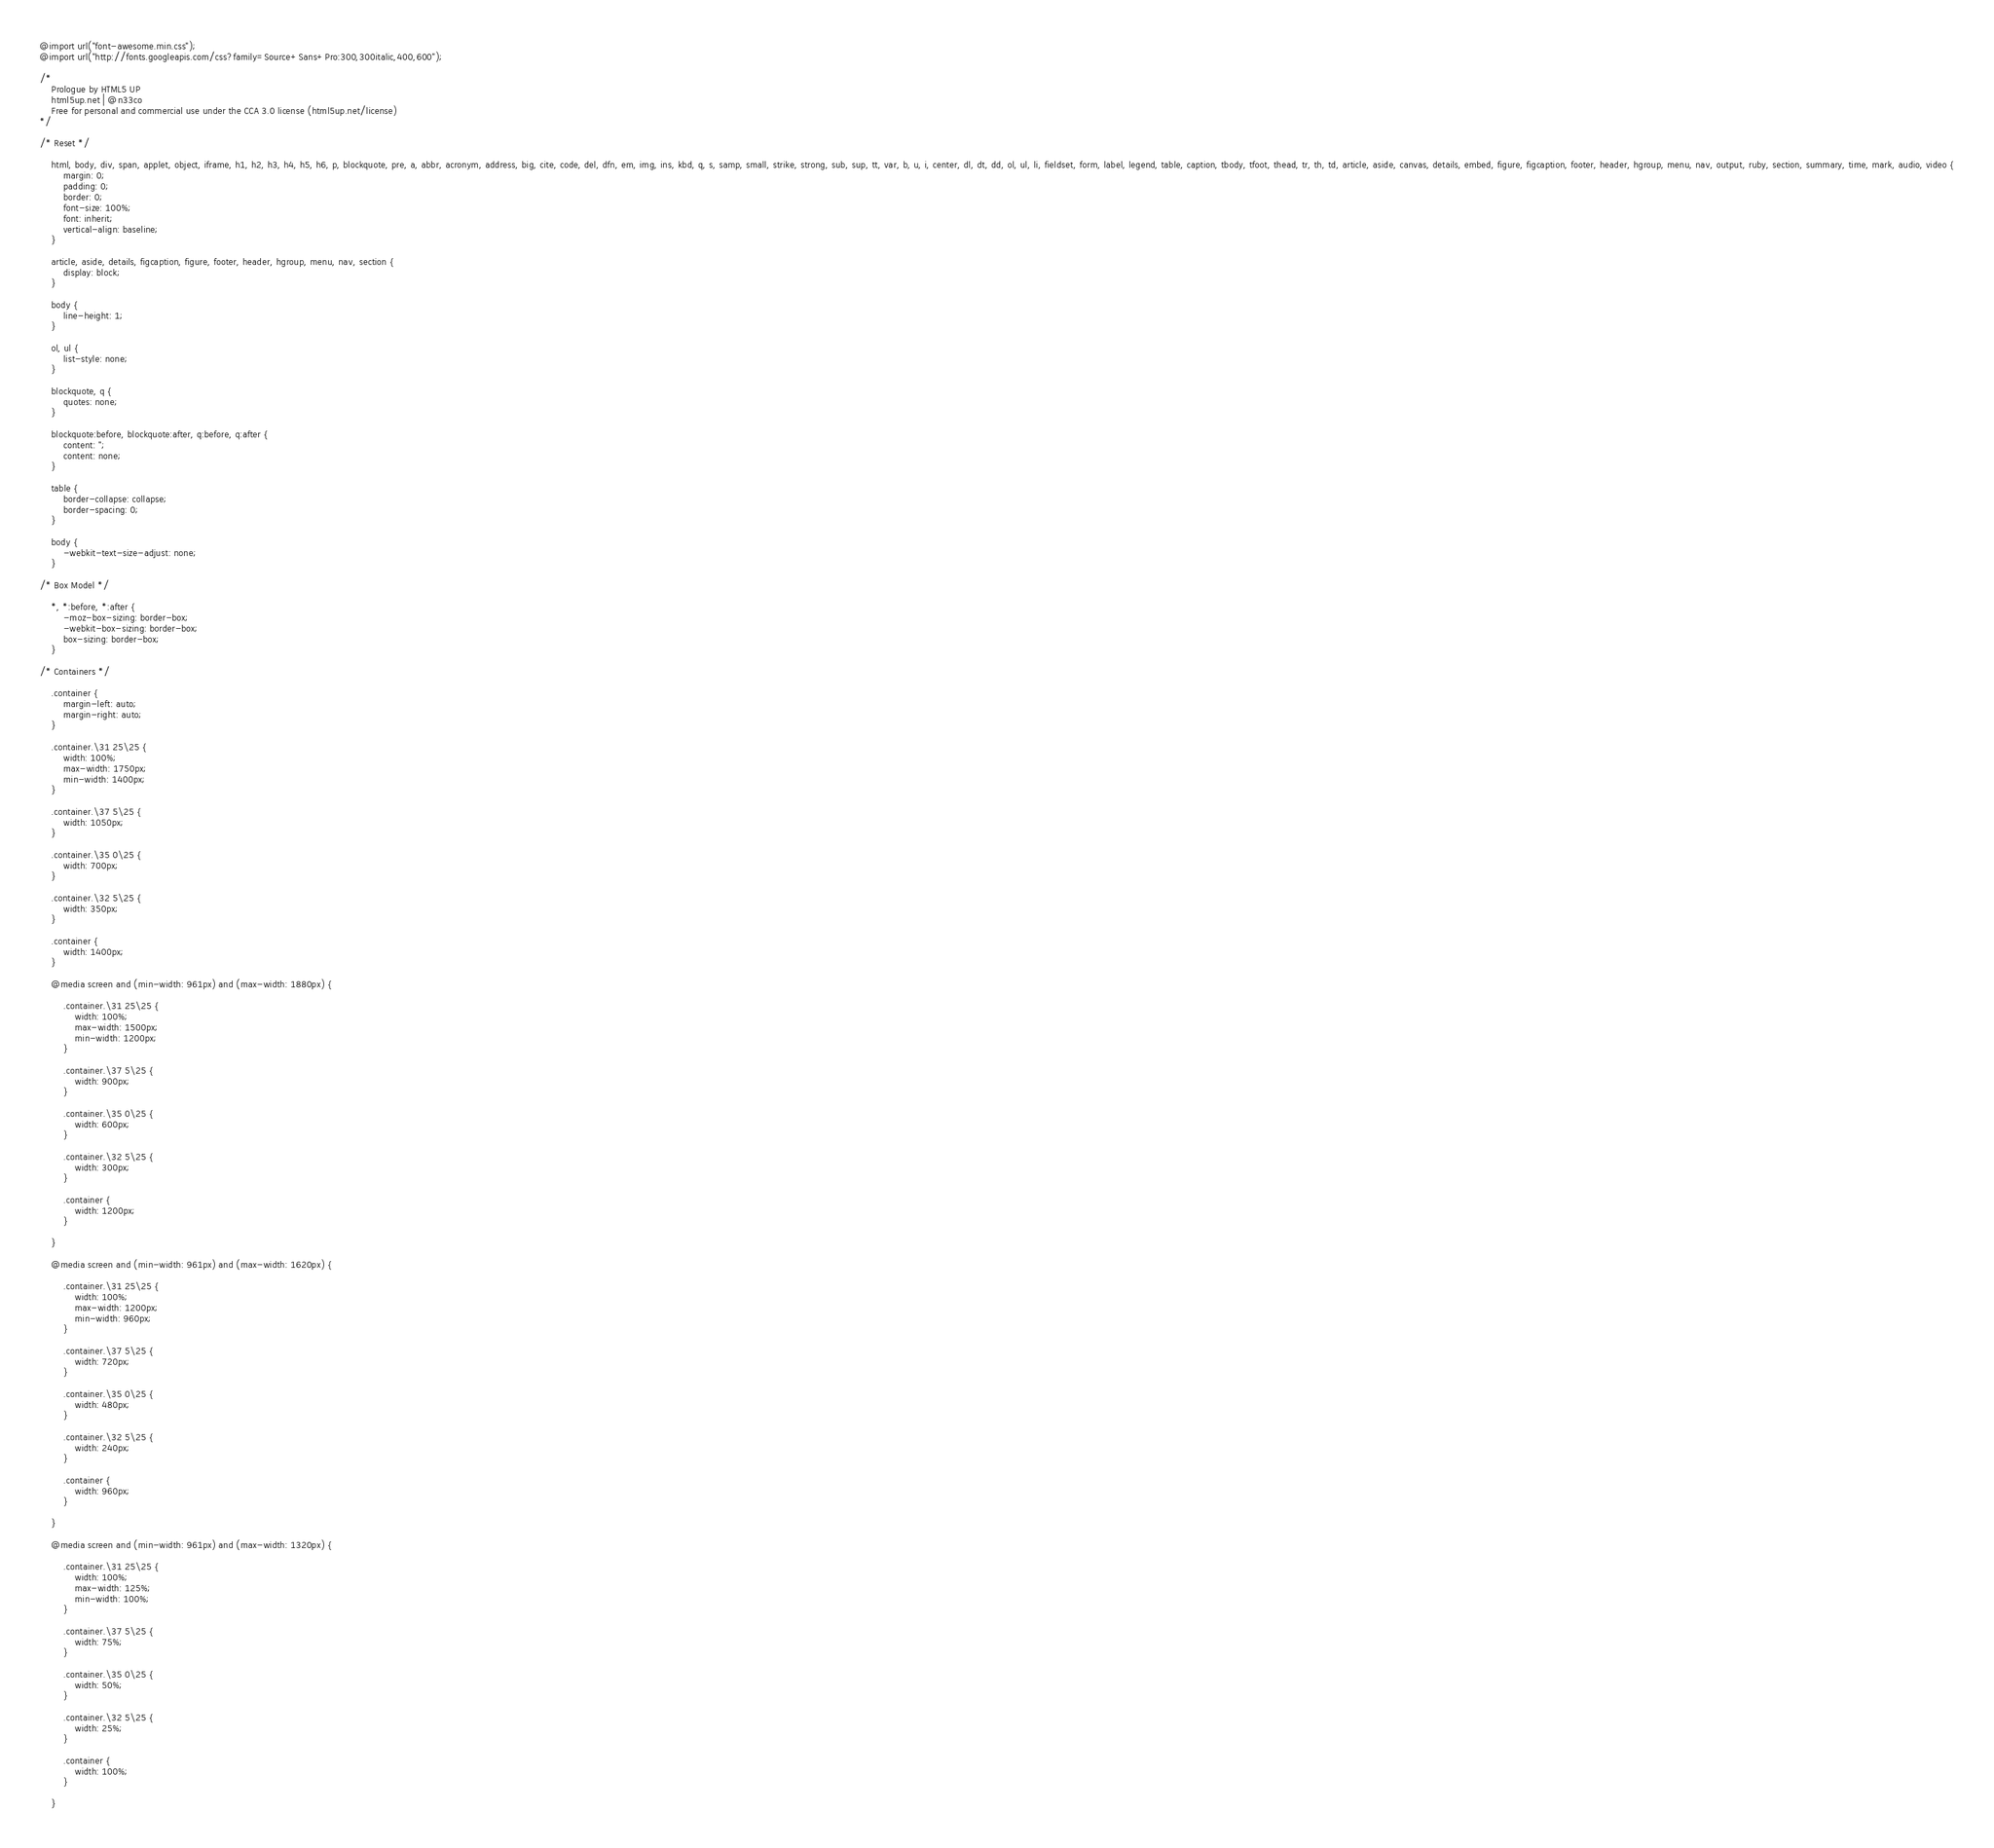Convert code to text. <code><loc_0><loc_0><loc_500><loc_500><_CSS_>@import url("font-awesome.min.css");
@import url("http://fonts.googleapis.com/css?family=Source+Sans+Pro:300,300italic,400,600");

/*
	Prologue by HTML5 UP
	html5up.net | @n33co
	Free for personal and commercial use under the CCA 3.0 license (html5up.net/license)
*/

/* Reset */

	html, body, div, span, applet, object, iframe, h1, h2, h3, h4, h5, h6, p, blockquote, pre, a, abbr, acronym, address, big, cite, code, del, dfn, em, img, ins, kbd, q, s, samp, small, strike, strong, sub, sup, tt, var, b, u, i, center, dl, dt, dd, ol, ul, li, fieldset, form, label, legend, table, caption, tbody, tfoot, thead, tr, th, td, article, aside, canvas, details, embed, figure, figcaption, footer, header, hgroup, menu, nav, output, ruby, section, summary, time, mark, audio, video {
		margin: 0;
		padding: 0;
		border: 0;
		font-size: 100%;
		font: inherit;
		vertical-align: baseline;
	}

	article, aside, details, figcaption, figure, footer, header, hgroup, menu, nav, section {
		display: block;
	}

	body {
		line-height: 1;
	}

	ol, ul {
		list-style: none;
	}

	blockquote, q {
		quotes: none;
	}

	blockquote:before, blockquote:after, q:before, q:after {
		content: '';
		content: none;
	}

	table {
		border-collapse: collapse;
		border-spacing: 0;
	}

	body {
		-webkit-text-size-adjust: none;
	}

/* Box Model */

	*, *:before, *:after {
		-moz-box-sizing: border-box;
		-webkit-box-sizing: border-box;
		box-sizing: border-box;
	}

/* Containers */

	.container {
		margin-left: auto;
		margin-right: auto;
	}

	.container.\31 25\25 {
		width: 100%;
		max-width: 1750px;
		min-width: 1400px;
	}

	.container.\37 5\25 {
		width: 1050px;
	}

	.container.\35 0\25 {
		width: 700px;
	}

	.container.\32 5\25 {
		width: 350px;
	}

	.container {
		width: 1400px;
	}

	@media screen and (min-width: 961px) and (max-width: 1880px) {

		.container.\31 25\25 {
			width: 100%;
			max-width: 1500px;
			min-width: 1200px;
		}

		.container.\37 5\25 {
			width: 900px;
		}

		.container.\35 0\25 {
			width: 600px;
		}

		.container.\32 5\25 {
			width: 300px;
		}

		.container {
			width: 1200px;
		}

	}

	@media screen and (min-width: 961px) and (max-width: 1620px) {

		.container.\31 25\25 {
			width: 100%;
			max-width: 1200px;
			min-width: 960px;
		}

		.container.\37 5\25 {
			width: 720px;
		}

		.container.\35 0\25 {
			width: 480px;
		}

		.container.\32 5\25 {
			width: 240px;
		}

		.container {
			width: 960px;
		}

	}

	@media screen and (min-width: 961px) and (max-width: 1320px) {

		.container.\31 25\25 {
			width: 100%;
			max-width: 125%;
			min-width: 100%;
		}

		.container.\37 5\25 {
			width: 75%;
		}

		.container.\35 0\25 {
			width: 50%;
		}

		.container.\32 5\25 {
			width: 25%;
		}

		.container {
			width: 100%;
		}

	}
</code> 